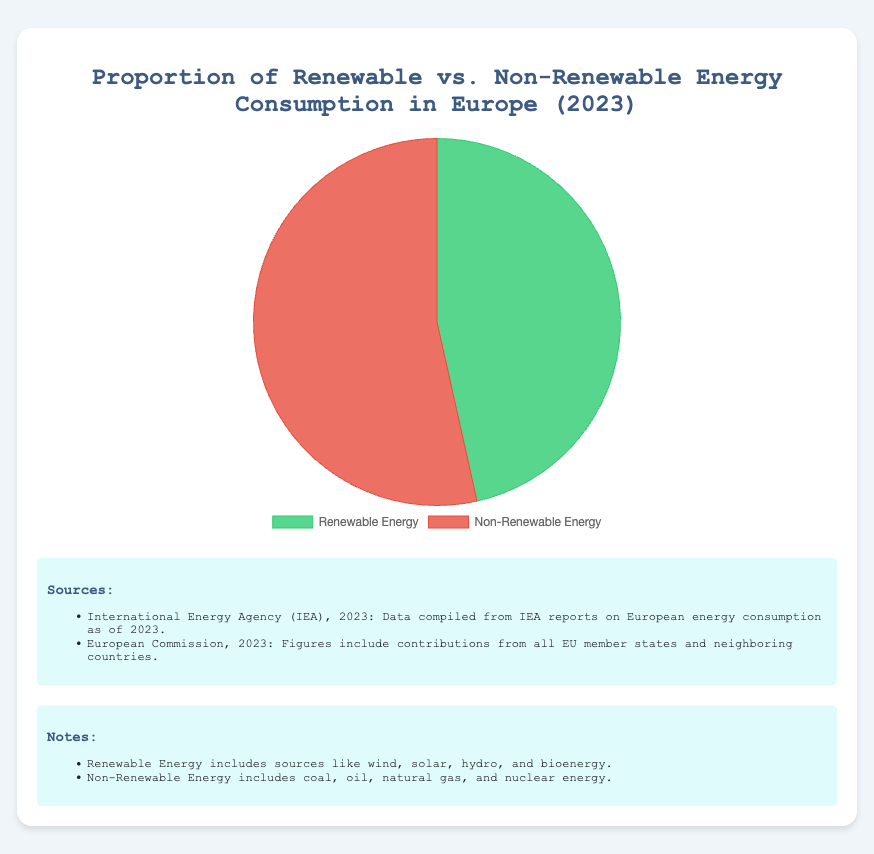What's the proportion of Renewable Energy consumption in Europe for 2023? The figure shows a pie chart with two segments, one for Renewable Energy and one for Non-Renewable Energy. The label for Renewable Energy shows 46.5%.
Answer: 46.5% How much higher is the Non-Renewable Energy consumption compared to Renewable Energy consumption in Europe? The Non-Renewable Energy consumption is 53.5% and Renewable Energy consumption is 46.5%. Subtracting the two gives 53.5% - 46.5% = 7%.
Answer: 7% Which type of energy has a higher proportion of consumption in Europe for 2023? Comparing the two segments on the pie chart, Non-Renewable Energy is 53.5% and Renewable Energy is 46.5%, indicating that Non-Renewable Energy has a higher proportion.
Answer: Non-Renewable Energy By how many percentage points does Non-Renewable Energy consumption exceed Renewable Energy consumption in Europe? The Non-Renewable Energy consumption is 53.5% and Renewable Energy consumption is 46.5%. The difference is 53.5 - 46.5 = 7 percentage points.
Answer: 7 percentage points What are the colors representing Renewable and Non-Renewable Energy in the pie chart? The pie chart shows Renewable Energy in green and Non-Renewable Energy in red, as indicated by the segments' colors.
Answer: Green and Red How much of the total energy consumption does Renewable Energy contribute to in Europe in 2023? The Renewable Energy segment of the pie chart represents 46.5% of the total energy consumption.
Answer: 46.5% Calculate the average proportion of Renewable and Non-Renewable Energy consumption in Europe. The proportions are 46.5% for Renewable and 53.5% for Non-Renewable Energy. The average is (46.5 + 53.5) / 2 = 50%.
Answer: 50% What type of energy occupies more than half of the pie chart? The Non-Renewable Energy segment of the pie chart occupies 53.5%, which is more than half of the pie chart.
Answer: Non-Renewable Energy If the consumption of Non-Renewable Energy dropped to 50%, how would the proportion of Renewable Energy have to change to maintain a total of 100%? With Non-Renewable Energy reduced to 50%, the remaining proportion must be taken up by Renewable Energy. Thus, Renewable Energy would rise to 100% - 50% = 50%.
Answer: 50% 